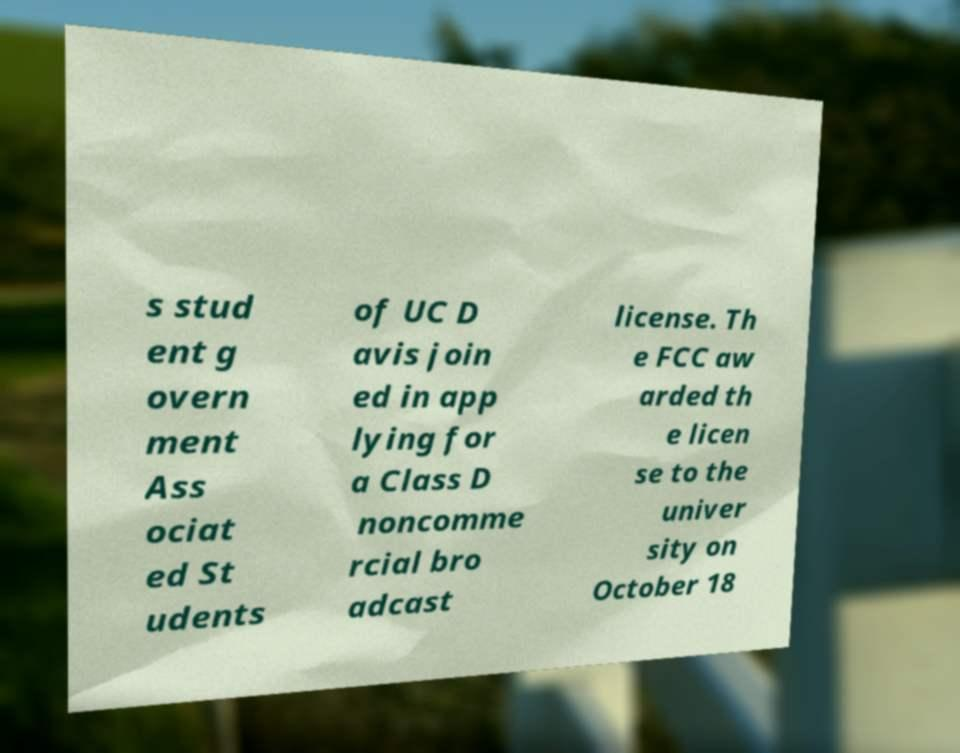What messages or text are displayed in this image? I need them in a readable, typed format. s stud ent g overn ment Ass ociat ed St udents of UC D avis join ed in app lying for a Class D noncomme rcial bro adcast license. Th e FCC aw arded th e licen se to the univer sity on October 18 